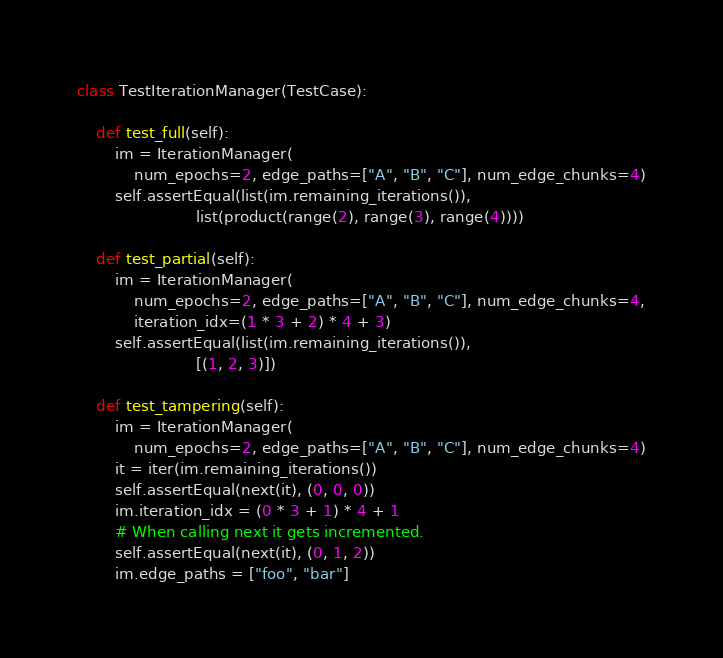<code> <loc_0><loc_0><loc_500><loc_500><_Python_>

class TestIterationManager(TestCase):

    def test_full(self):
        im = IterationManager(
            num_epochs=2, edge_paths=["A", "B", "C"], num_edge_chunks=4)
        self.assertEqual(list(im.remaining_iterations()),
                         list(product(range(2), range(3), range(4))))

    def test_partial(self):
        im = IterationManager(
            num_epochs=2, edge_paths=["A", "B", "C"], num_edge_chunks=4,
            iteration_idx=(1 * 3 + 2) * 4 + 3)
        self.assertEqual(list(im.remaining_iterations()),
                         [(1, 2, 3)])

    def test_tampering(self):
        im = IterationManager(
            num_epochs=2, edge_paths=["A", "B", "C"], num_edge_chunks=4)
        it = iter(im.remaining_iterations())
        self.assertEqual(next(it), (0, 0, 0))
        im.iteration_idx = (0 * 3 + 1) * 4 + 1
        # When calling next it gets incremented.
        self.assertEqual(next(it), (0, 1, 2))
        im.edge_paths = ["foo", "bar"]</code> 